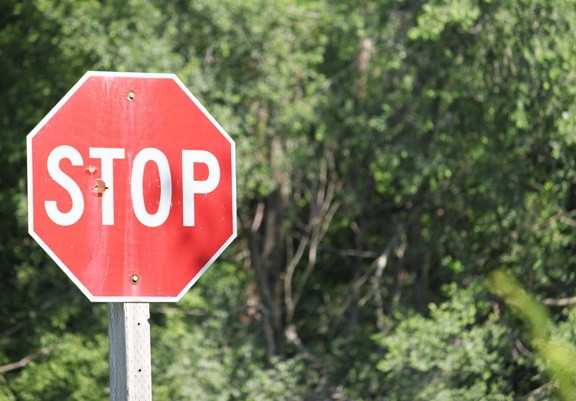Describe the objects in this image and their specific colors. I can see a stop sign in black, salmon, white, and red tones in this image. 